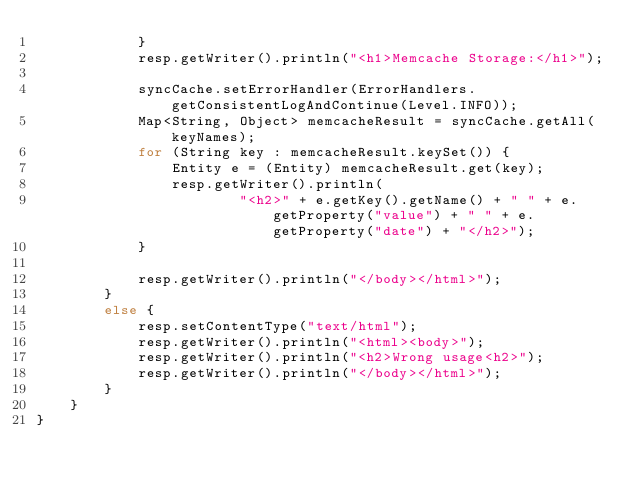Convert code to text. <code><loc_0><loc_0><loc_500><loc_500><_Java_>            }
            resp.getWriter().println("<h1>Memcache Storage:</h1>");

            syncCache.setErrorHandler(ErrorHandlers.getConsistentLogAndContinue(Level.INFO));
            Map<String, Object> memcacheResult = syncCache.getAll(keyNames);
            for (String key : memcacheResult.keySet()) {
                Entity e = (Entity) memcacheResult.get(key);
                resp.getWriter().println(
                        "<h2>" + e.getKey().getName() + " " + e.getProperty("value") + " " + e.getProperty("date") + "</h2>");
            }

            resp.getWriter().println("</body></html>");
        }
        else {
            resp.setContentType("text/html");
            resp.getWriter().println("<html><body>");
            resp.getWriter().println("<h2>Wrong usage<h2>");
            resp.getWriter().println("</body></html>");
        }
    }
}</code> 